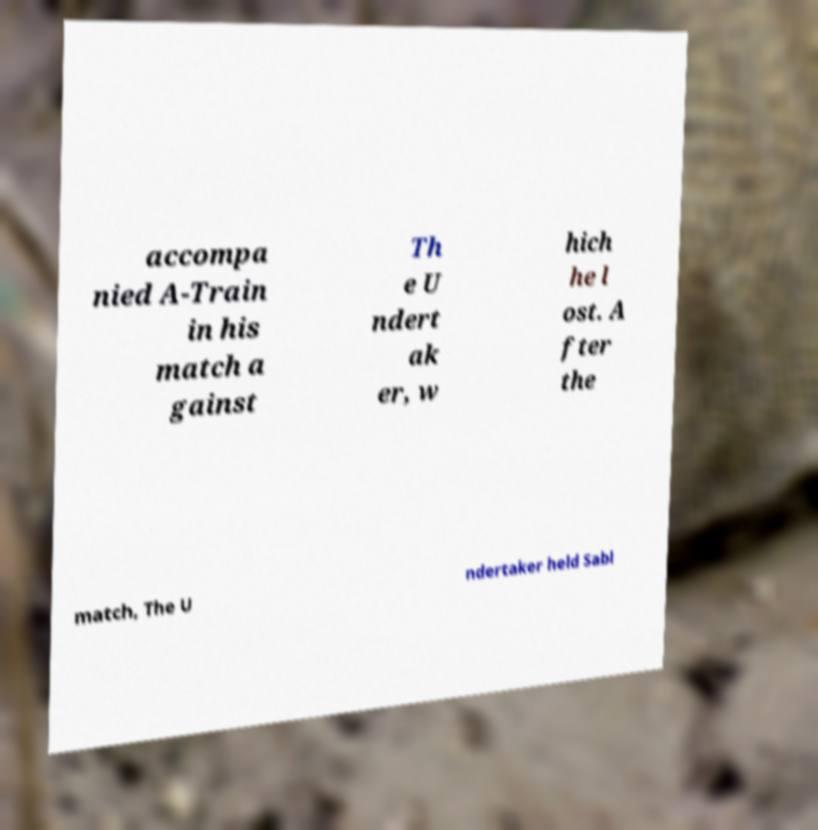Can you accurately transcribe the text from the provided image for me? accompa nied A-Train in his match a gainst Th e U ndert ak er, w hich he l ost. A fter the match, The U ndertaker held Sabl 